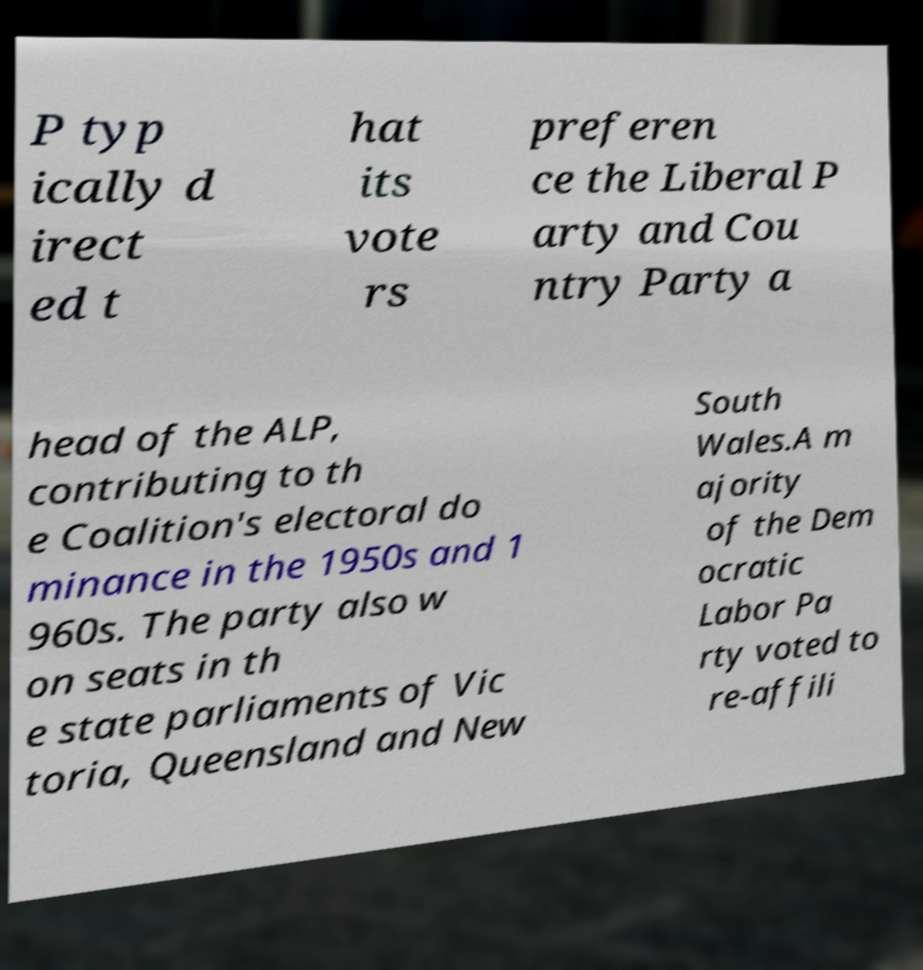Can you read and provide the text displayed in the image?This photo seems to have some interesting text. Can you extract and type it out for me? P typ ically d irect ed t hat its vote rs preferen ce the Liberal P arty and Cou ntry Party a head of the ALP, contributing to th e Coalition's electoral do minance in the 1950s and 1 960s. The party also w on seats in th e state parliaments of Vic toria, Queensland and New South Wales.A m ajority of the Dem ocratic Labor Pa rty voted to re-affili 